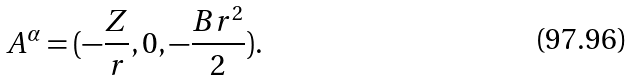<formula> <loc_0><loc_0><loc_500><loc_500>A ^ { \alpha } = ( - \frac { Z } { r } , 0 , - \frac { { B } r ^ { 2 } } 2 ) .</formula> 